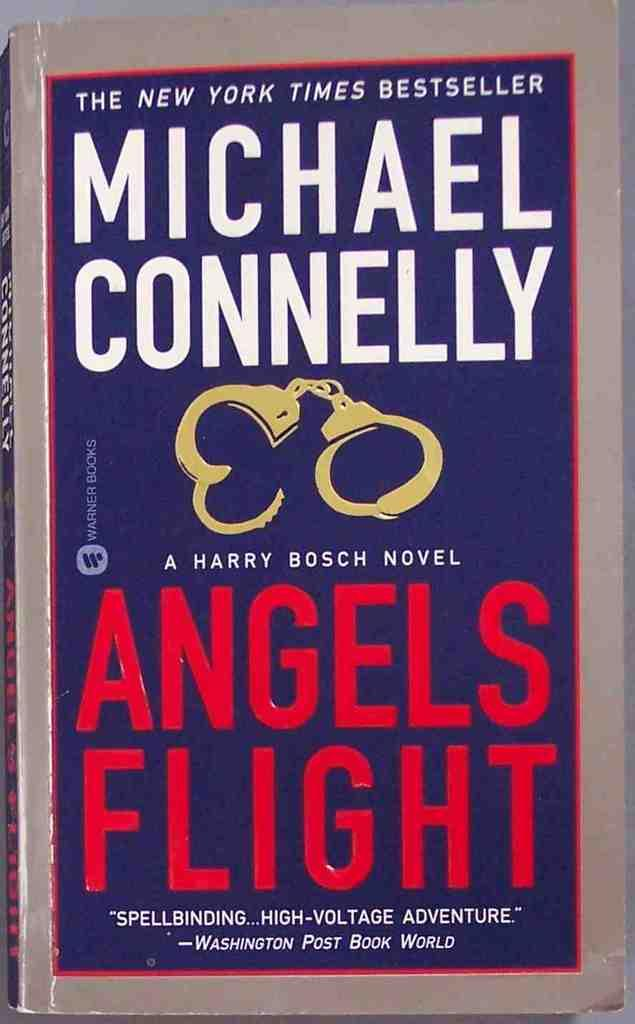<image>
Describe the image concisely. a blue book that is called Angels Flight 